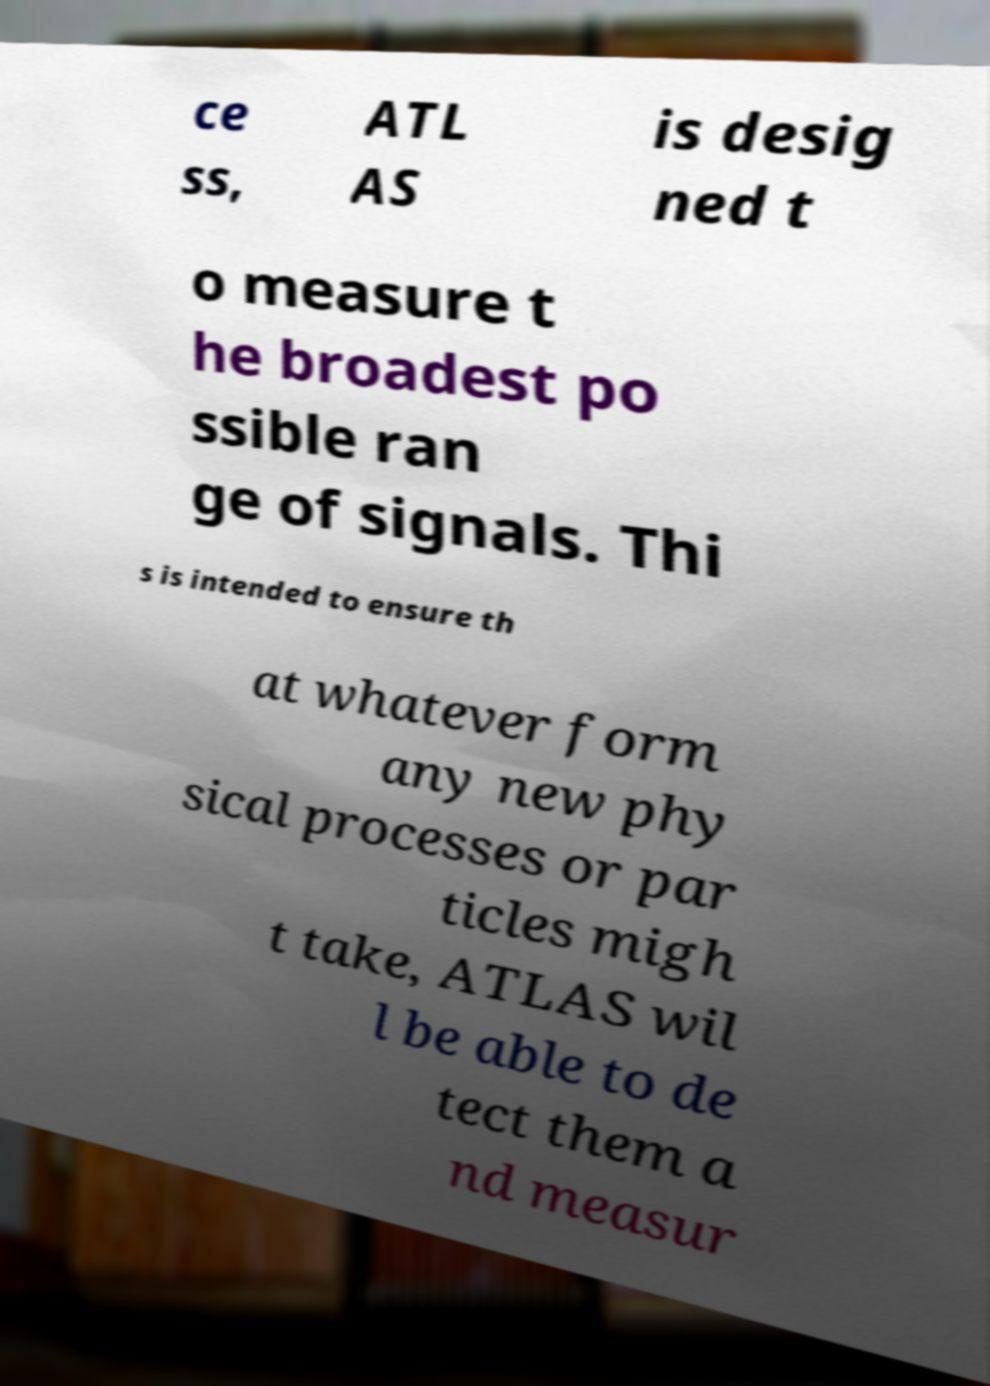Can you accurately transcribe the text from the provided image for me? ce ss, ATL AS is desig ned t o measure t he broadest po ssible ran ge of signals. Thi s is intended to ensure th at whatever form any new phy sical processes or par ticles migh t take, ATLAS wil l be able to de tect them a nd measur 